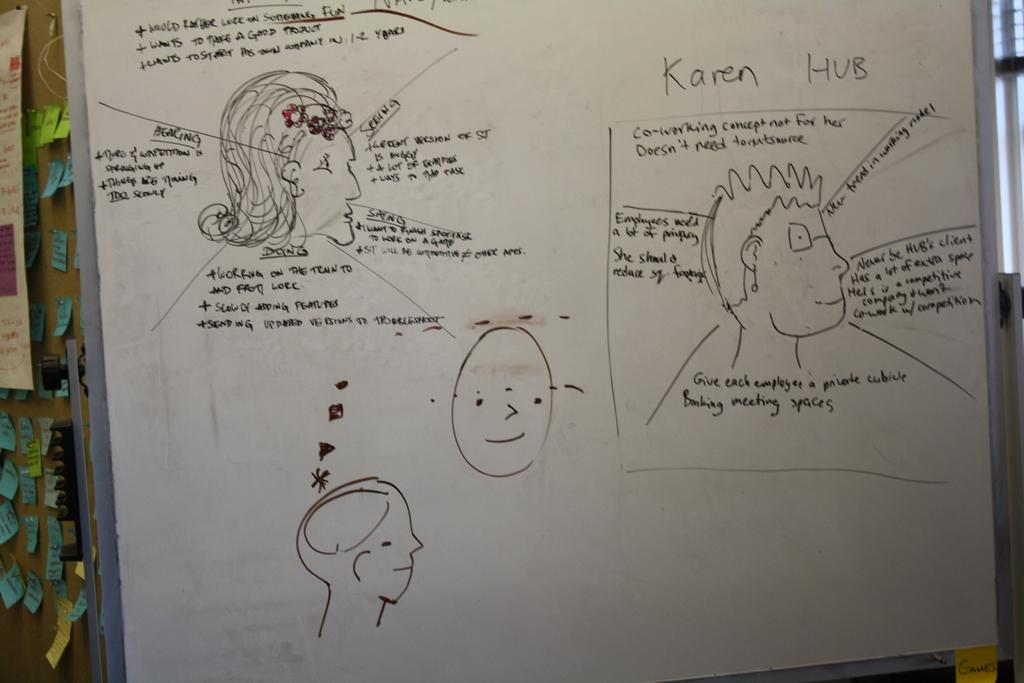What can be seen on the posters in the image? The posters have drawings and text written on them. Can you describe the drawings on the posters? Unfortunately, the specific details of the drawings cannot be determined from the provided facts. What type of information is written on the posters? The text on the posters provides some form of information or message, but the exact content cannot be determined from the provided facts. What substance is increasing in the image? There is no substance or increase mentioned in the provided facts, so this question cannot be answered. 